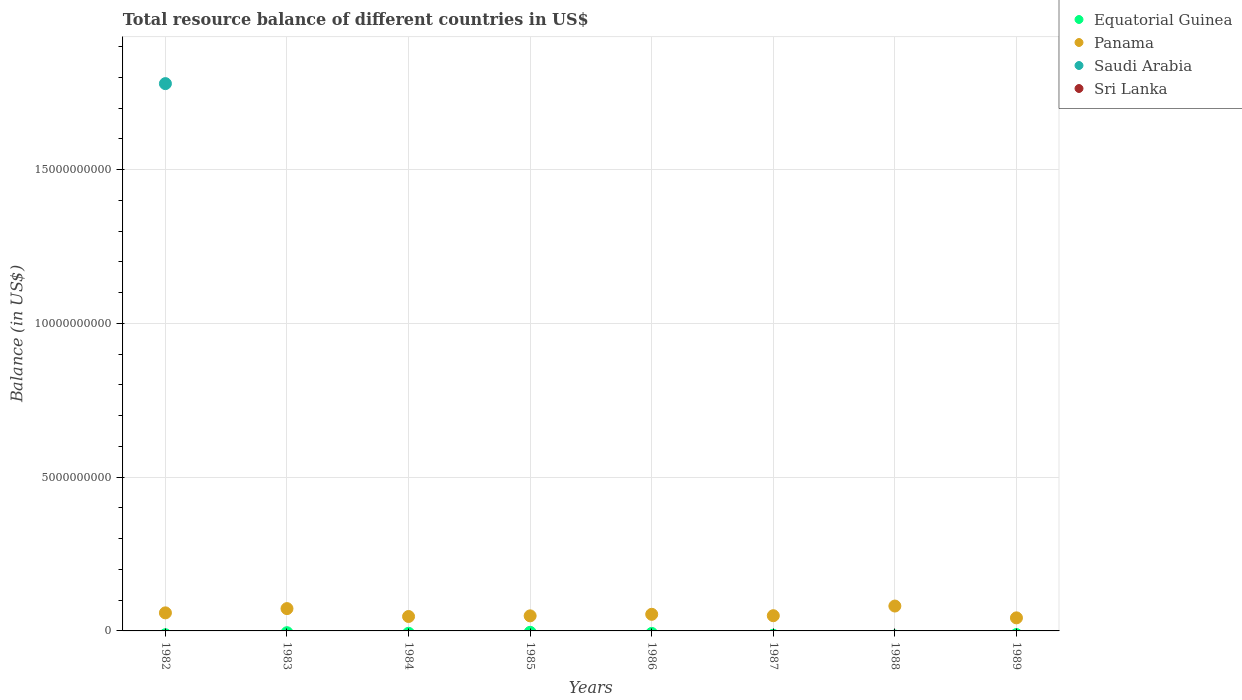How many different coloured dotlines are there?
Offer a terse response. 2. Is the number of dotlines equal to the number of legend labels?
Give a very brief answer. No. What is the total resource balance in Panama in 1983?
Your answer should be very brief. 7.26e+08. Across all years, what is the maximum total resource balance in Saudi Arabia?
Keep it short and to the point. 1.78e+1. Across all years, what is the minimum total resource balance in Panama?
Your response must be concise. 4.24e+08. In which year was the total resource balance in Panama maximum?
Give a very brief answer. 1988. What is the total total resource balance in Saudi Arabia in the graph?
Your answer should be compact. 1.78e+1. What is the difference between the total resource balance in Panama in 1983 and that in 1985?
Ensure brevity in your answer.  2.36e+08. What is the difference between the total resource balance in Sri Lanka in 1985 and the total resource balance in Equatorial Guinea in 1982?
Your answer should be compact. 0. What is the average total resource balance in Saudi Arabia per year?
Provide a succinct answer. 2.22e+09. In the year 1982, what is the difference between the total resource balance in Saudi Arabia and total resource balance in Panama?
Make the answer very short. 1.72e+1. What is the difference between the highest and the second highest total resource balance in Panama?
Your answer should be compact. 8.31e+07. What is the difference between the highest and the lowest total resource balance in Saudi Arabia?
Give a very brief answer. 1.78e+1. In how many years, is the total resource balance in Equatorial Guinea greater than the average total resource balance in Equatorial Guinea taken over all years?
Ensure brevity in your answer.  0. Does the total resource balance in Saudi Arabia monotonically increase over the years?
Provide a short and direct response. No. Is the total resource balance in Equatorial Guinea strictly greater than the total resource balance in Sri Lanka over the years?
Offer a terse response. Yes. How many dotlines are there?
Ensure brevity in your answer.  2. How many years are there in the graph?
Provide a short and direct response. 8. What is the difference between two consecutive major ticks on the Y-axis?
Your answer should be compact. 5.00e+09. Where does the legend appear in the graph?
Your answer should be compact. Top right. How are the legend labels stacked?
Your answer should be very brief. Vertical. What is the title of the graph?
Offer a very short reply. Total resource balance of different countries in US$. What is the label or title of the Y-axis?
Ensure brevity in your answer.  Balance (in US$). What is the Balance (in US$) of Equatorial Guinea in 1982?
Provide a succinct answer. 0. What is the Balance (in US$) in Panama in 1982?
Provide a succinct answer. 5.87e+08. What is the Balance (in US$) of Saudi Arabia in 1982?
Keep it short and to the point. 1.78e+1. What is the Balance (in US$) in Equatorial Guinea in 1983?
Your answer should be very brief. 0. What is the Balance (in US$) of Panama in 1983?
Offer a terse response. 7.26e+08. What is the Balance (in US$) of Saudi Arabia in 1983?
Provide a succinct answer. 0. What is the Balance (in US$) of Equatorial Guinea in 1984?
Ensure brevity in your answer.  0. What is the Balance (in US$) of Panama in 1984?
Provide a short and direct response. 4.69e+08. What is the Balance (in US$) of Saudi Arabia in 1984?
Provide a short and direct response. 0. What is the Balance (in US$) in Equatorial Guinea in 1985?
Offer a very short reply. 0. What is the Balance (in US$) in Panama in 1985?
Your answer should be very brief. 4.90e+08. What is the Balance (in US$) of Saudi Arabia in 1985?
Provide a succinct answer. 0. What is the Balance (in US$) of Sri Lanka in 1985?
Keep it short and to the point. 0. What is the Balance (in US$) of Panama in 1986?
Offer a terse response. 5.40e+08. What is the Balance (in US$) of Saudi Arabia in 1986?
Offer a terse response. 0. What is the Balance (in US$) of Sri Lanka in 1986?
Ensure brevity in your answer.  0. What is the Balance (in US$) in Panama in 1987?
Your answer should be compact. 4.95e+08. What is the Balance (in US$) of Panama in 1988?
Ensure brevity in your answer.  8.09e+08. What is the Balance (in US$) of Panama in 1989?
Offer a very short reply. 4.24e+08. Across all years, what is the maximum Balance (in US$) in Panama?
Ensure brevity in your answer.  8.09e+08. Across all years, what is the maximum Balance (in US$) of Saudi Arabia?
Make the answer very short. 1.78e+1. Across all years, what is the minimum Balance (in US$) of Panama?
Keep it short and to the point. 4.24e+08. What is the total Balance (in US$) in Equatorial Guinea in the graph?
Give a very brief answer. 0. What is the total Balance (in US$) of Panama in the graph?
Offer a terse response. 4.54e+09. What is the total Balance (in US$) of Saudi Arabia in the graph?
Provide a short and direct response. 1.78e+1. What is the total Balance (in US$) of Sri Lanka in the graph?
Your response must be concise. 0. What is the difference between the Balance (in US$) of Panama in 1982 and that in 1983?
Offer a terse response. -1.39e+08. What is the difference between the Balance (in US$) of Panama in 1982 and that in 1984?
Your answer should be very brief. 1.18e+08. What is the difference between the Balance (in US$) in Panama in 1982 and that in 1985?
Make the answer very short. 9.72e+07. What is the difference between the Balance (in US$) in Panama in 1982 and that in 1986?
Provide a succinct answer. 4.68e+07. What is the difference between the Balance (in US$) of Panama in 1982 and that in 1987?
Ensure brevity in your answer.  9.24e+07. What is the difference between the Balance (in US$) in Panama in 1982 and that in 1988?
Your answer should be compact. -2.22e+08. What is the difference between the Balance (in US$) in Panama in 1982 and that in 1989?
Offer a terse response. 1.63e+08. What is the difference between the Balance (in US$) in Panama in 1983 and that in 1984?
Your answer should be very brief. 2.57e+08. What is the difference between the Balance (in US$) of Panama in 1983 and that in 1985?
Your answer should be very brief. 2.36e+08. What is the difference between the Balance (in US$) of Panama in 1983 and that in 1986?
Offer a very short reply. 1.86e+08. What is the difference between the Balance (in US$) of Panama in 1983 and that in 1987?
Your answer should be very brief. 2.31e+08. What is the difference between the Balance (in US$) of Panama in 1983 and that in 1988?
Ensure brevity in your answer.  -8.31e+07. What is the difference between the Balance (in US$) in Panama in 1983 and that in 1989?
Ensure brevity in your answer.  3.01e+08. What is the difference between the Balance (in US$) in Panama in 1984 and that in 1985?
Make the answer very short. -2.09e+07. What is the difference between the Balance (in US$) in Panama in 1984 and that in 1986?
Provide a succinct answer. -7.13e+07. What is the difference between the Balance (in US$) in Panama in 1984 and that in 1987?
Keep it short and to the point. -2.57e+07. What is the difference between the Balance (in US$) in Panama in 1984 and that in 1988?
Your answer should be compact. -3.40e+08. What is the difference between the Balance (in US$) of Panama in 1984 and that in 1989?
Provide a succinct answer. 4.45e+07. What is the difference between the Balance (in US$) of Panama in 1985 and that in 1986?
Your answer should be very brief. -5.04e+07. What is the difference between the Balance (in US$) in Panama in 1985 and that in 1987?
Provide a succinct answer. -4.80e+06. What is the difference between the Balance (in US$) of Panama in 1985 and that in 1988?
Give a very brief answer. -3.19e+08. What is the difference between the Balance (in US$) in Panama in 1985 and that in 1989?
Give a very brief answer. 6.54e+07. What is the difference between the Balance (in US$) of Panama in 1986 and that in 1987?
Give a very brief answer. 4.56e+07. What is the difference between the Balance (in US$) of Panama in 1986 and that in 1988?
Give a very brief answer. -2.69e+08. What is the difference between the Balance (in US$) of Panama in 1986 and that in 1989?
Offer a very short reply. 1.16e+08. What is the difference between the Balance (in US$) in Panama in 1987 and that in 1988?
Provide a succinct answer. -3.14e+08. What is the difference between the Balance (in US$) of Panama in 1987 and that in 1989?
Your response must be concise. 7.02e+07. What is the difference between the Balance (in US$) in Panama in 1988 and that in 1989?
Your answer should be very brief. 3.84e+08. What is the average Balance (in US$) in Equatorial Guinea per year?
Your response must be concise. 0. What is the average Balance (in US$) of Panama per year?
Provide a succinct answer. 5.68e+08. What is the average Balance (in US$) of Saudi Arabia per year?
Keep it short and to the point. 2.22e+09. What is the average Balance (in US$) of Sri Lanka per year?
Ensure brevity in your answer.  0. In the year 1982, what is the difference between the Balance (in US$) of Panama and Balance (in US$) of Saudi Arabia?
Ensure brevity in your answer.  -1.72e+1. What is the ratio of the Balance (in US$) in Panama in 1982 to that in 1983?
Keep it short and to the point. 0.81. What is the ratio of the Balance (in US$) of Panama in 1982 to that in 1984?
Ensure brevity in your answer.  1.25. What is the ratio of the Balance (in US$) in Panama in 1982 to that in 1985?
Provide a short and direct response. 1.2. What is the ratio of the Balance (in US$) of Panama in 1982 to that in 1986?
Keep it short and to the point. 1.09. What is the ratio of the Balance (in US$) of Panama in 1982 to that in 1987?
Provide a short and direct response. 1.19. What is the ratio of the Balance (in US$) of Panama in 1982 to that in 1988?
Keep it short and to the point. 0.73. What is the ratio of the Balance (in US$) of Panama in 1982 to that in 1989?
Your answer should be very brief. 1.38. What is the ratio of the Balance (in US$) in Panama in 1983 to that in 1984?
Your answer should be compact. 1.55. What is the ratio of the Balance (in US$) in Panama in 1983 to that in 1985?
Offer a terse response. 1.48. What is the ratio of the Balance (in US$) in Panama in 1983 to that in 1986?
Your answer should be very brief. 1.34. What is the ratio of the Balance (in US$) in Panama in 1983 to that in 1987?
Your answer should be compact. 1.47. What is the ratio of the Balance (in US$) of Panama in 1983 to that in 1988?
Keep it short and to the point. 0.9. What is the ratio of the Balance (in US$) in Panama in 1983 to that in 1989?
Your response must be concise. 1.71. What is the ratio of the Balance (in US$) in Panama in 1984 to that in 1985?
Your answer should be very brief. 0.96. What is the ratio of the Balance (in US$) in Panama in 1984 to that in 1986?
Make the answer very short. 0.87. What is the ratio of the Balance (in US$) of Panama in 1984 to that in 1987?
Give a very brief answer. 0.95. What is the ratio of the Balance (in US$) of Panama in 1984 to that in 1988?
Your answer should be compact. 0.58. What is the ratio of the Balance (in US$) of Panama in 1984 to that in 1989?
Your answer should be compact. 1.1. What is the ratio of the Balance (in US$) of Panama in 1985 to that in 1986?
Provide a short and direct response. 0.91. What is the ratio of the Balance (in US$) in Panama in 1985 to that in 1987?
Your answer should be very brief. 0.99. What is the ratio of the Balance (in US$) in Panama in 1985 to that in 1988?
Make the answer very short. 0.61. What is the ratio of the Balance (in US$) of Panama in 1985 to that in 1989?
Your answer should be very brief. 1.15. What is the ratio of the Balance (in US$) in Panama in 1986 to that in 1987?
Your answer should be compact. 1.09. What is the ratio of the Balance (in US$) of Panama in 1986 to that in 1988?
Provide a succinct answer. 0.67. What is the ratio of the Balance (in US$) of Panama in 1986 to that in 1989?
Provide a short and direct response. 1.27. What is the ratio of the Balance (in US$) in Panama in 1987 to that in 1988?
Make the answer very short. 0.61. What is the ratio of the Balance (in US$) of Panama in 1987 to that in 1989?
Your answer should be very brief. 1.17. What is the ratio of the Balance (in US$) of Panama in 1988 to that in 1989?
Your answer should be very brief. 1.91. What is the difference between the highest and the second highest Balance (in US$) of Panama?
Give a very brief answer. 8.31e+07. What is the difference between the highest and the lowest Balance (in US$) of Panama?
Your response must be concise. 3.84e+08. What is the difference between the highest and the lowest Balance (in US$) in Saudi Arabia?
Make the answer very short. 1.78e+1. 